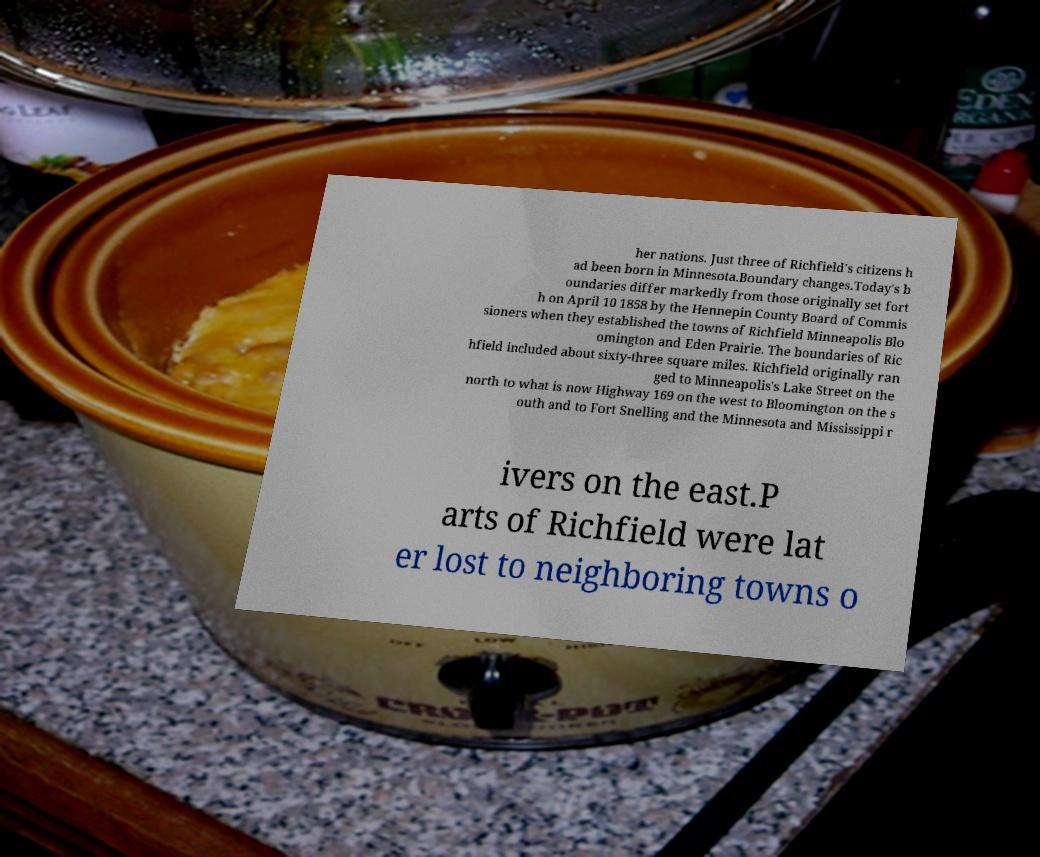For documentation purposes, I need the text within this image transcribed. Could you provide that? her nations. Just three of Richfield's citizens h ad been born in Minnesota.Boundary changes.Today's b oundaries differ markedly from those originally set fort h on April 10 1858 by the Hennepin County Board of Commis sioners when they established the towns of Richfield Minneapolis Blo omington and Eden Prairie. The boundaries of Ric hfield included about sixty-three square miles. Richfield originally ran ged to Minneapolis's Lake Street on the north to what is now Highway 169 on the west to Bloomington on the s outh and to Fort Snelling and the Minnesota and Mississippi r ivers on the east.P arts of Richfield were lat er lost to neighboring towns o 